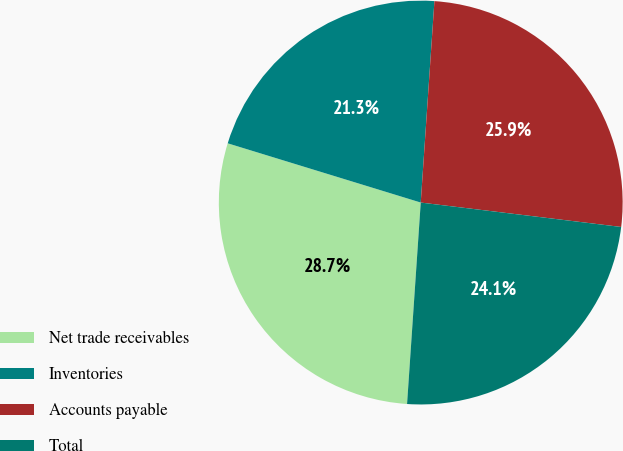<chart> <loc_0><loc_0><loc_500><loc_500><pie_chart><fcel>Net trade receivables<fcel>Inventories<fcel>Accounts payable<fcel>Total<nl><fcel>28.66%<fcel>21.34%<fcel>25.85%<fcel>24.15%<nl></chart> 